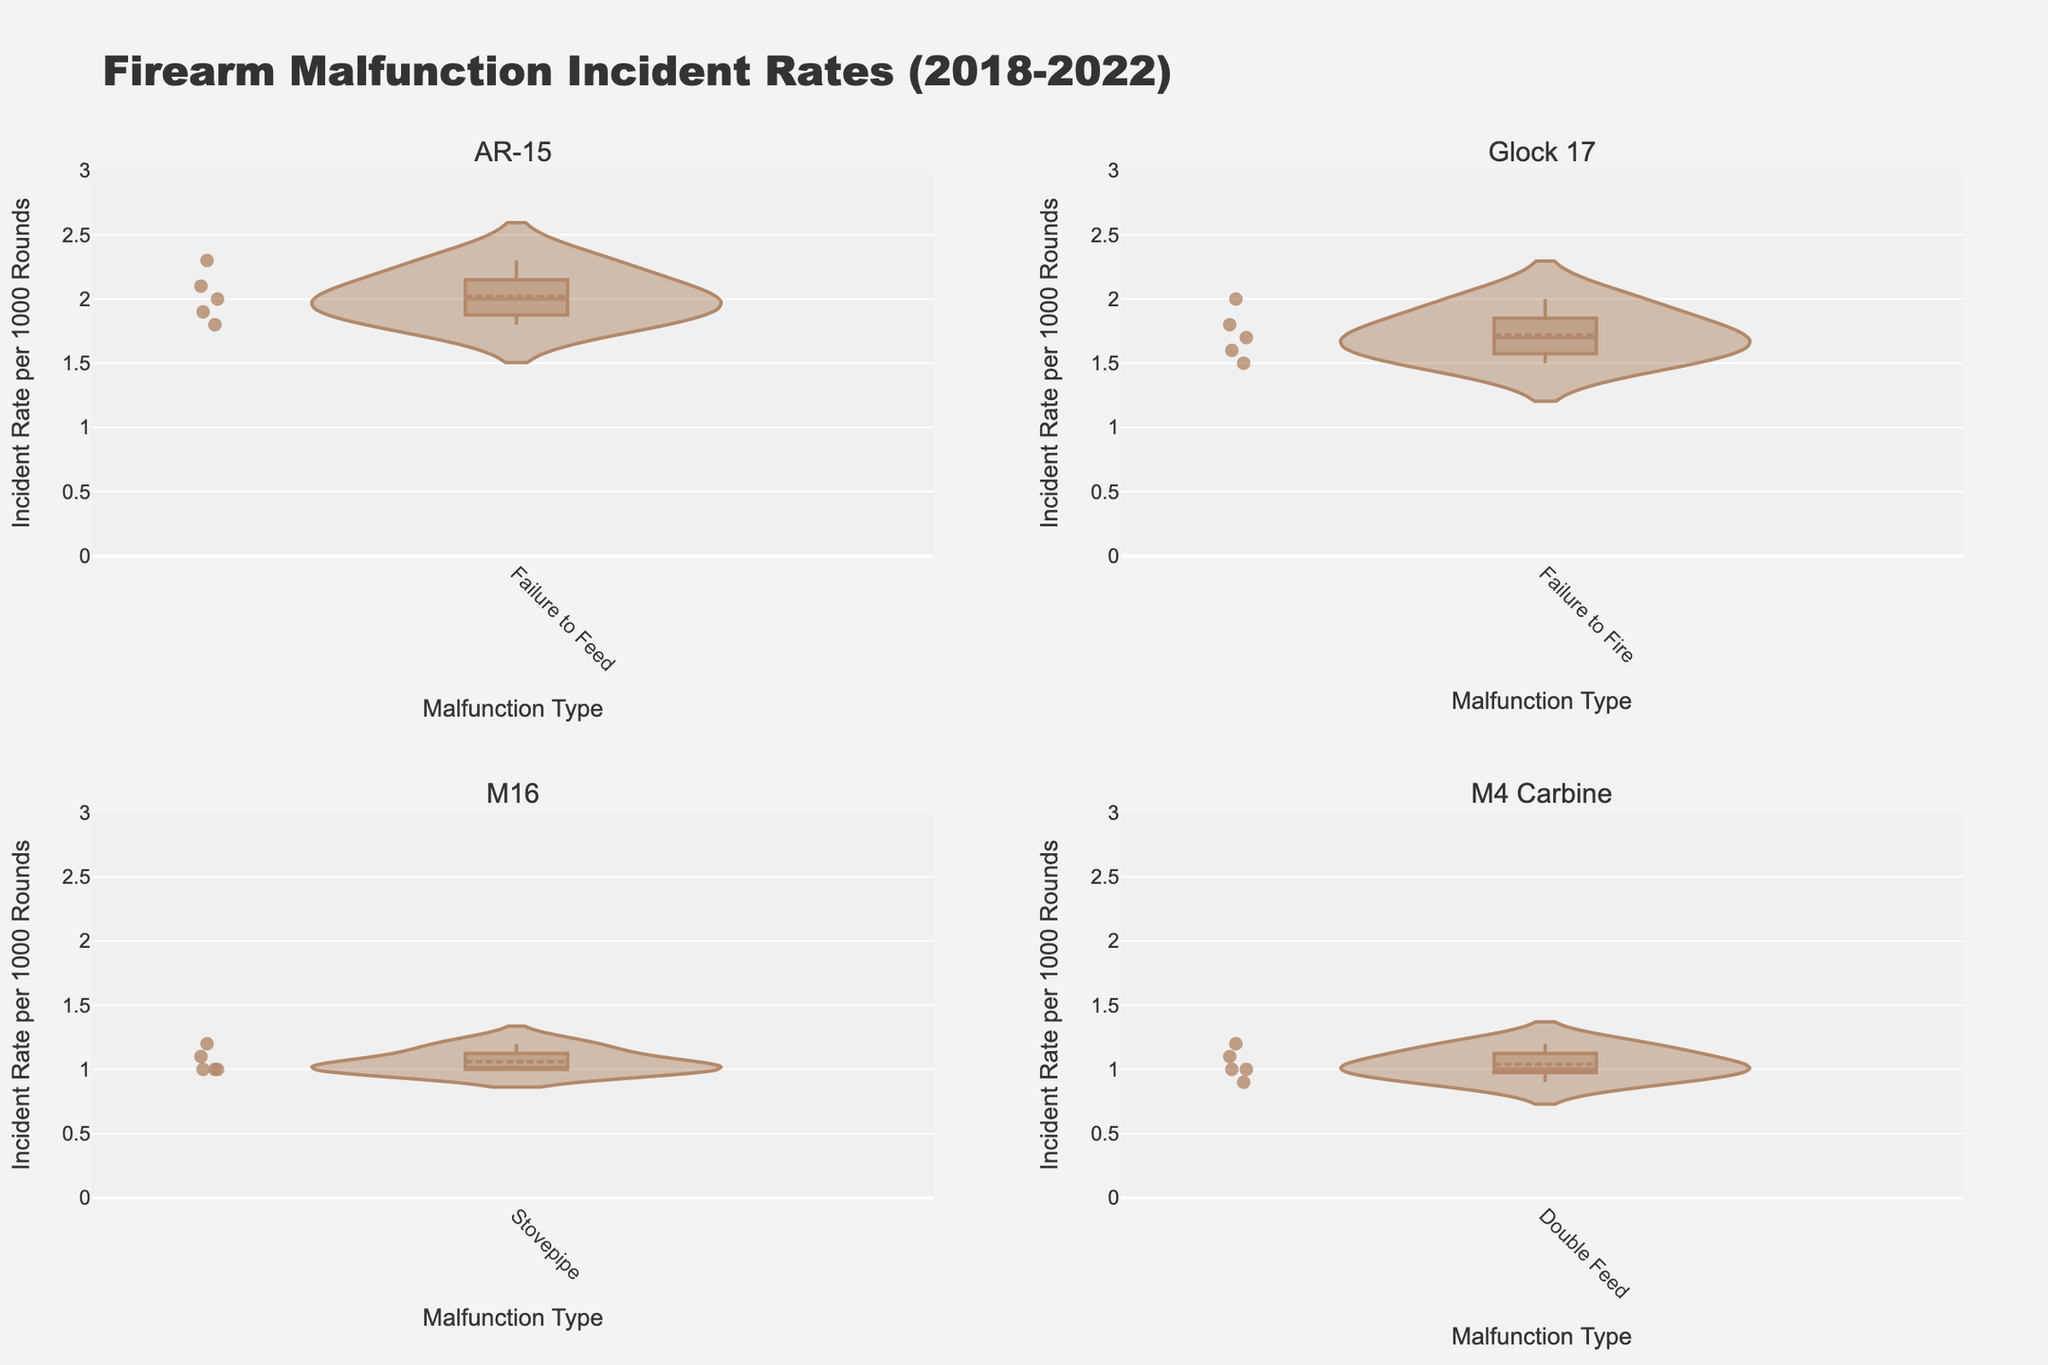How many unique firearm types are present in the figure? Look at the subplot titles or the labels in each subplot to identify the number of unique firearm types.
Answer: 4 What is the average incident rate for the "Failure to Fire" malfunction in the Glock 17 between 2018 and 2022? Sum the incident rates for the "Failure to Fire" malfunction in the Glock 17 subplot and divide by the number of years: (1.8 + 2.0 + 1.7 + 1.6 + 1.5) / 5.
Answer: 1.72 Which firearm type has the highest median incident rate for "Failure to Feed"? Look at the box plots of "Failure to Feed" malfunction for each firearm type and identify which one has the highest median line.
Answer: AR-15 Are there any years where the incident rate for "Double Feed" in M4 Carbine is exactly 1.0? Check the points on the violin plot for "Double Feed" in the M4 Carbine subplot to see if there are points at 1.0.
Answer: Yes Between AR-15 and M16, which firearm type has a more consistent incident rate for the "Stovepipe" malfunction over the years? Compare the spread of the "Stovepipe" violin plots for AR-15 and M16. Consistency can be inferred by a narrower spread.
Answer: M16 